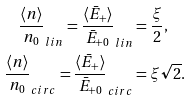<formula> <loc_0><loc_0><loc_500><loc_500>\frac { \langle n \rangle } { n _ { 0 } } _ { l i n } = \frac { \langle \bar { E } _ { + } \rangle } { \bar { E } _ { + 0 } } _ { l i n } & = \frac { \xi } { 2 } , \\ \frac { \langle n \rangle } { n _ { 0 } } _ { c i r c } = \frac { \langle \bar { E } _ { + } \rangle } { \bar { E } _ { + 0 } } _ { c i r c } & = \xi \sqrt { 2 } .</formula> 